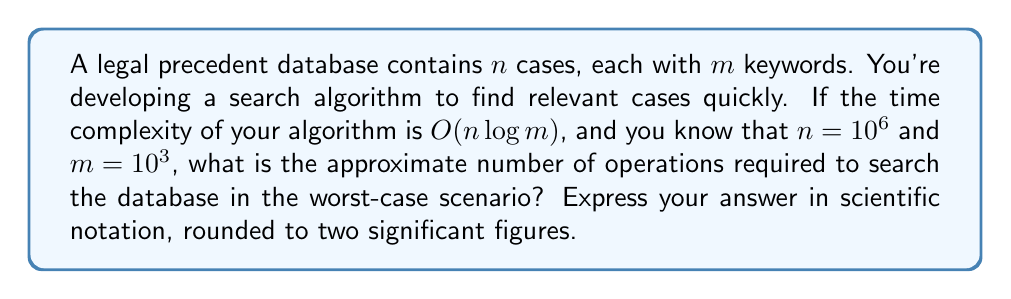Can you answer this question? To solve this problem, we need to follow these steps:

1) The time complexity of the algorithm is $O(n \log m)$. This means that in the worst case, the number of operations is proportional to $n \log m$.

2) We are given that $n = 10^6$ and $m = 10^3$.

3) Let's calculate $n \log m$:
   
   $n \log m = 10^6 \log 10^3$

4) Using the logarithm property $\log a^b = b \log a$, we can simplify:
   
   $10^6 \log 10^3 = 10^6 \cdot 3 \log 10$

5) $\log 10$ is approximately equal to 2.302585093.

6) So, our calculation becomes:
   
   $10^6 \cdot 3 \cdot 2.302585093 \approx 6,907,755,279$

7) Rounding to two significant figures, we get $6.9 \times 10^9$.

Therefore, the approximate number of operations required in the worst-case scenario is $6.9 \times 10^9$.
Answer: $6.9 \times 10^9$ 